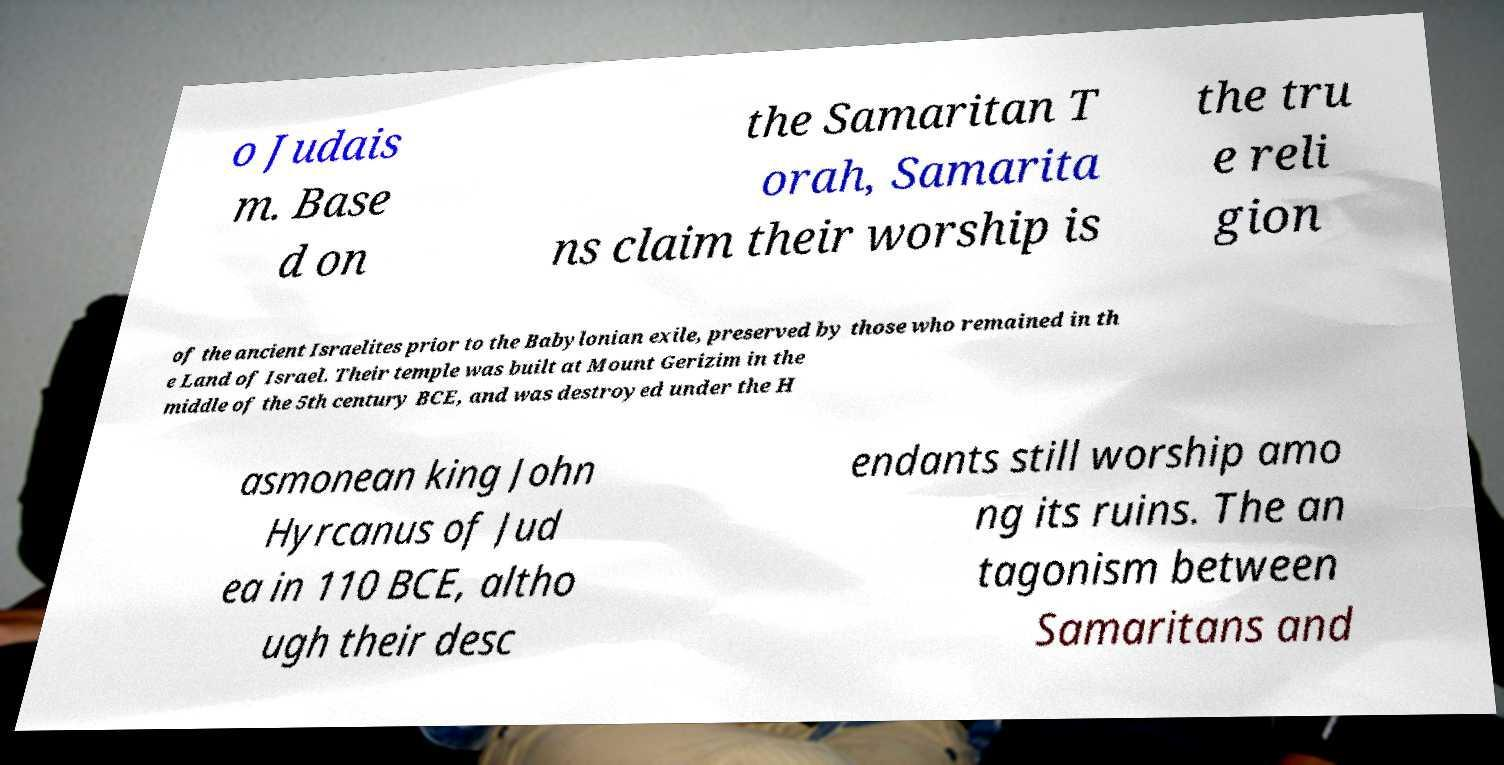Can you accurately transcribe the text from the provided image for me? o Judais m. Base d on the Samaritan T orah, Samarita ns claim their worship is the tru e reli gion of the ancient Israelites prior to the Babylonian exile, preserved by those who remained in th e Land of Israel. Their temple was built at Mount Gerizim in the middle of the 5th century BCE, and was destroyed under the H asmonean king John Hyrcanus of Jud ea in 110 BCE, altho ugh their desc endants still worship amo ng its ruins. The an tagonism between Samaritans and 